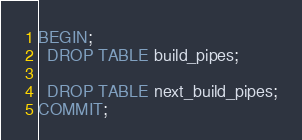Convert code to text. <code><loc_0><loc_0><loc_500><loc_500><_SQL_>BEGIN;
  DROP TABLE build_pipes;

  DROP TABLE next_build_pipes;
COMMIT;
</code> 